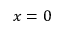<formula> <loc_0><loc_0><loc_500><loc_500>x = 0</formula> 